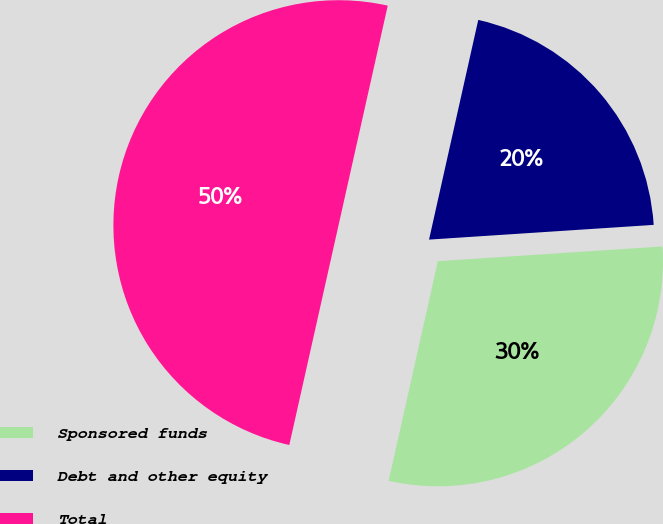Convert chart. <chart><loc_0><loc_0><loc_500><loc_500><pie_chart><fcel>Sponsored funds<fcel>Debt and other equity<fcel>Total<nl><fcel>29.55%<fcel>20.45%<fcel>50.0%<nl></chart> 